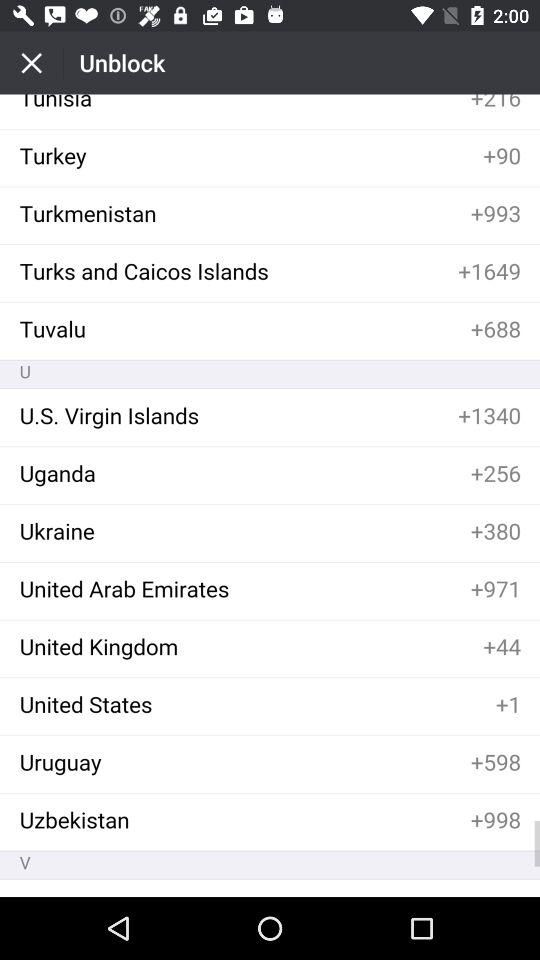What is Uganda's country code? Uganda's country code is +256. 